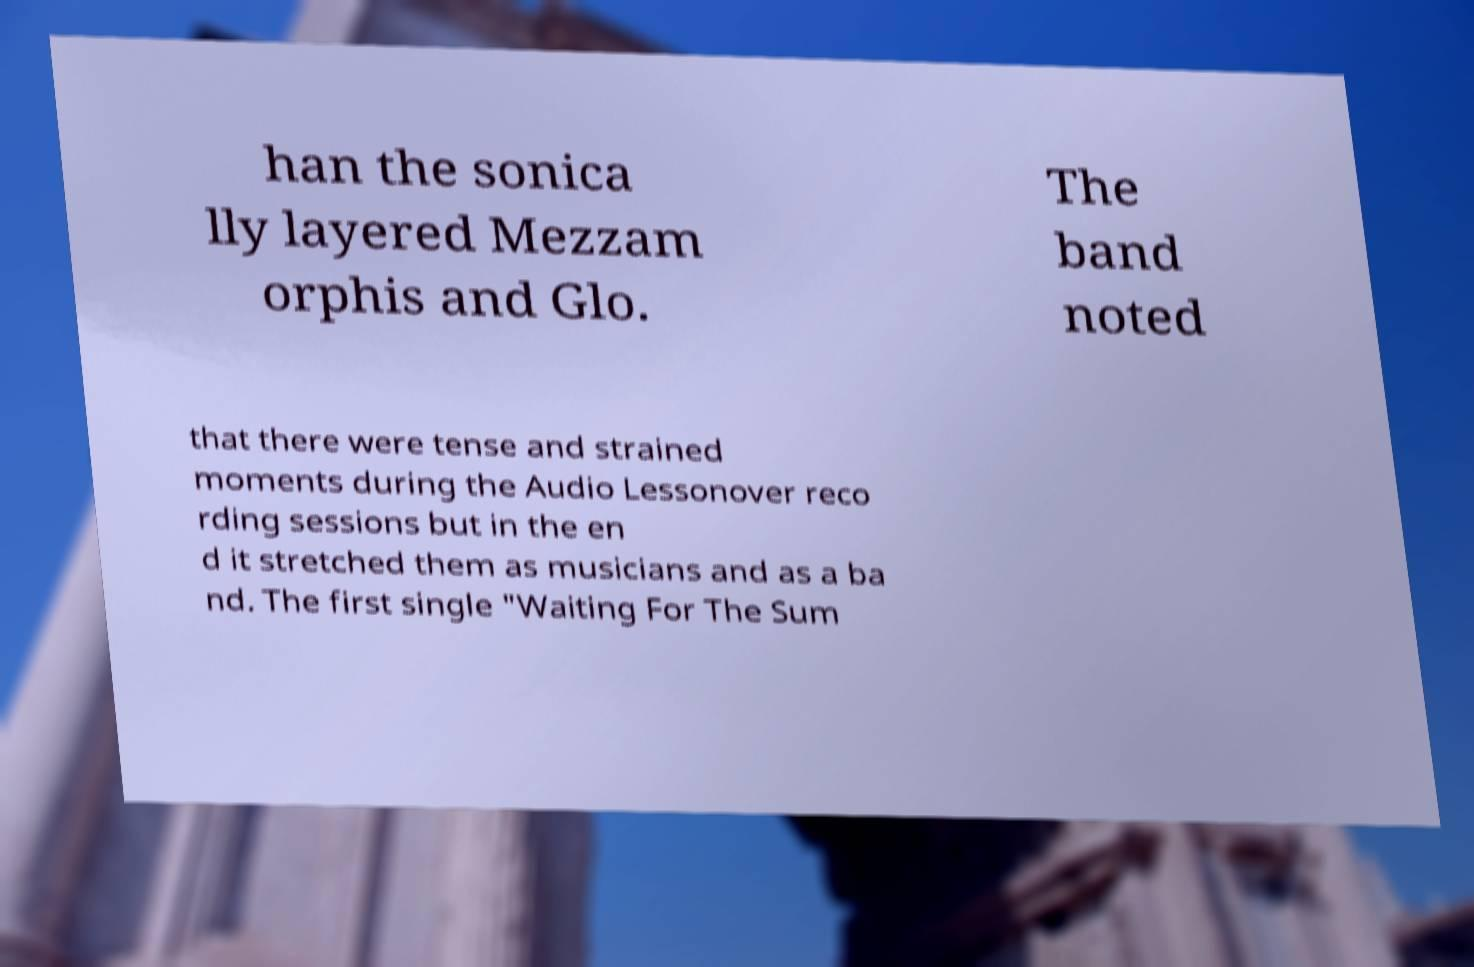I need the written content from this picture converted into text. Can you do that? han the sonica lly layered Mezzam orphis and Glo. The band noted that there were tense and strained moments during the Audio Lessonover reco rding sessions but in the en d it stretched them as musicians and as a ba nd. The first single "Waiting For The Sum 